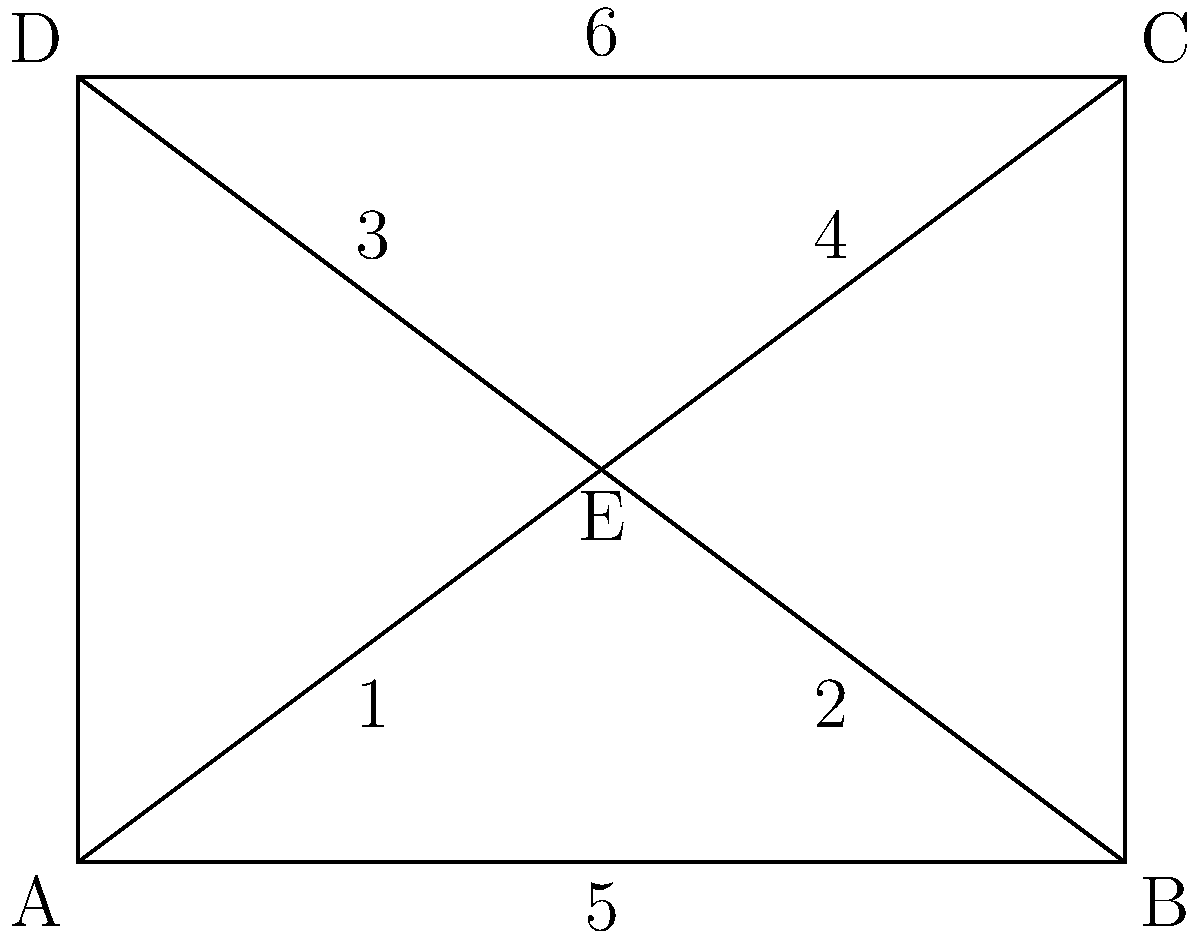In the diagram representing a foldable device's hinge mechanism, which pair of angles are congruent when the device is partially folded? To identify congruent angles in this folding mechanism, we need to analyze the properties of the diagram:

1. The diagram shows a rectangle ABCD with diagonals AE and CE intersecting at point E.

2. In a rectangle, opposite sides are parallel and equal in length.

3. When a line intersects two parallel lines, corresponding angles are congruent.

4. The diagonals of a rectangle bisect each other, meaning AE = EC and BE = ED.

5. When two lines intersect, vertical angles are congruent.

6. In this case, angles 1 and 4 are vertical angles, as are angles 2 and 3.

7. Additionally, angles 1 and 2 are corresponding angles formed by line AE intersecting parallel lines AD and BC.

8. Similarly, angles 3 and 4 are corresponding angles formed by line CE intersecting parallel lines AD and BC.

Therefore, we can conclude that angles 1 and 4 are congruent, as are angles 2 and 3. Angles 5 and 6 are not part of the intersecting lines and thus not relevant to this congruence relationship.
Answer: Angles 1 and 4, Angles 2 and 3 